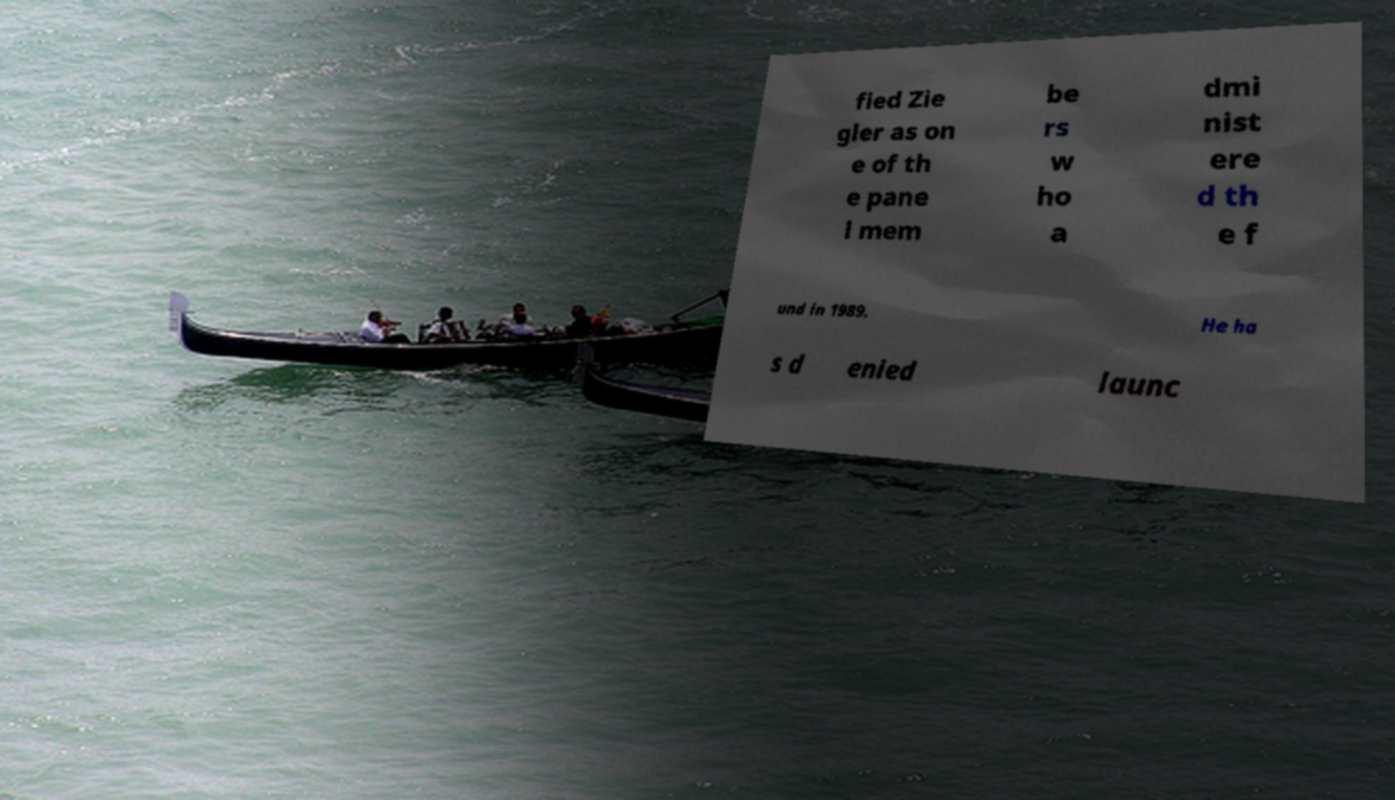Can you read and provide the text displayed in the image?This photo seems to have some interesting text. Can you extract and type it out for me? fied Zie gler as on e of th e pane l mem be rs w ho a dmi nist ere d th e f und in 1989. He ha s d enied launc 